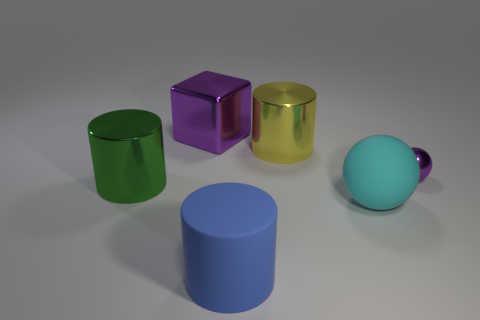Subtract all large rubber cylinders. How many cylinders are left? 2 Subtract all yellow cylinders. How many cylinders are left? 2 Add 4 green things. How many objects exist? 10 Subtract all spheres. How many objects are left? 4 Add 4 small cylinders. How many small cylinders exist? 4 Subtract 1 cyan balls. How many objects are left? 5 Subtract all brown cylinders. Subtract all cyan blocks. How many cylinders are left? 3 Subtract all tiny purple spheres. Subtract all blue cylinders. How many objects are left? 4 Add 1 big cyan rubber balls. How many big cyan rubber balls are left? 2 